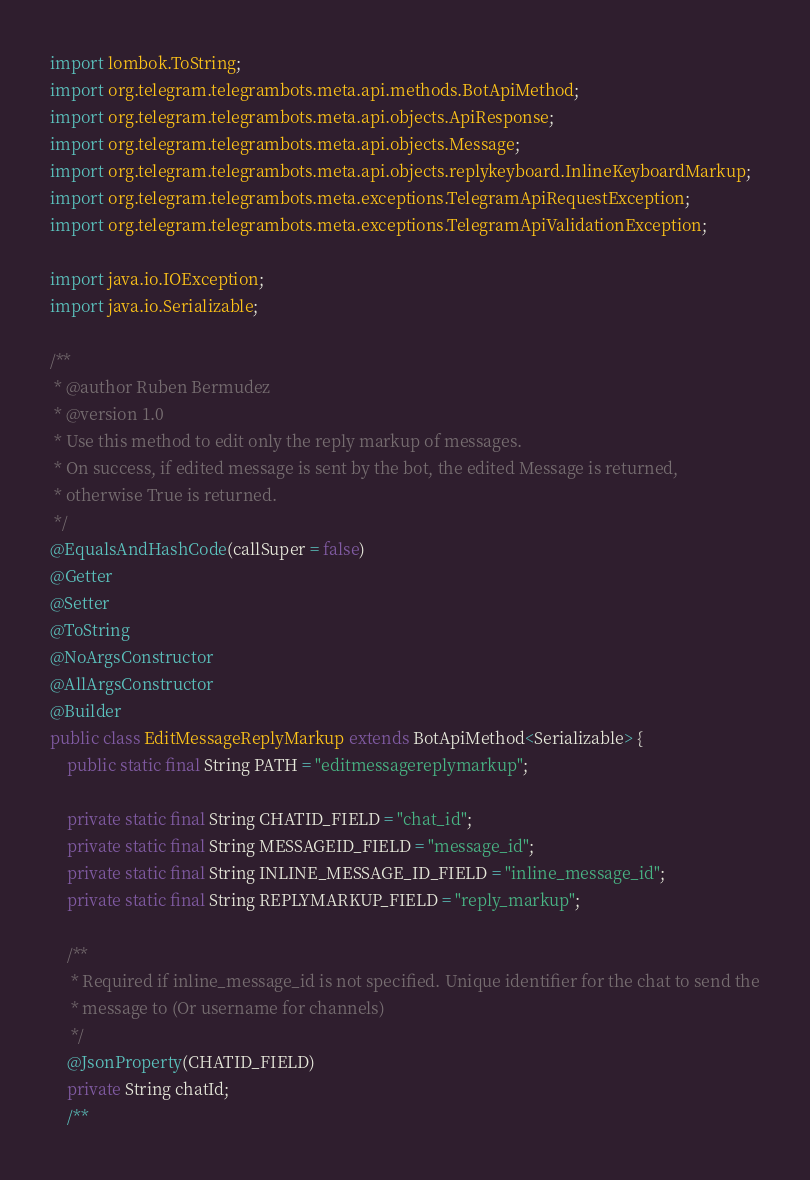Convert code to text. <code><loc_0><loc_0><loc_500><loc_500><_Java_>import lombok.ToString;
import org.telegram.telegrambots.meta.api.methods.BotApiMethod;
import org.telegram.telegrambots.meta.api.objects.ApiResponse;
import org.telegram.telegrambots.meta.api.objects.Message;
import org.telegram.telegrambots.meta.api.objects.replykeyboard.InlineKeyboardMarkup;
import org.telegram.telegrambots.meta.exceptions.TelegramApiRequestException;
import org.telegram.telegrambots.meta.exceptions.TelegramApiValidationException;

import java.io.IOException;
import java.io.Serializable;

/**
 * @author Ruben Bermudez
 * @version 1.0
 * Use this method to edit only the reply markup of messages.
 * On success, if edited message is sent by the bot, the edited Message is returned,
 * otherwise True is returned.
 */
@EqualsAndHashCode(callSuper = false)
@Getter
@Setter
@ToString
@NoArgsConstructor
@AllArgsConstructor
@Builder
public class EditMessageReplyMarkup extends BotApiMethod<Serializable> {
    public static final String PATH = "editmessagereplymarkup";

    private static final String CHATID_FIELD = "chat_id";
    private static final String MESSAGEID_FIELD = "message_id";
    private static final String INLINE_MESSAGE_ID_FIELD = "inline_message_id";
    private static final String REPLYMARKUP_FIELD = "reply_markup";

    /**
     * Required if inline_message_id is not specified. Unique identifier for the chat to send the
     * message to (Or username for channels)
     */
    @JsonProperty(CHATID_FIELD)
    private String chatId;
    /**</code> 